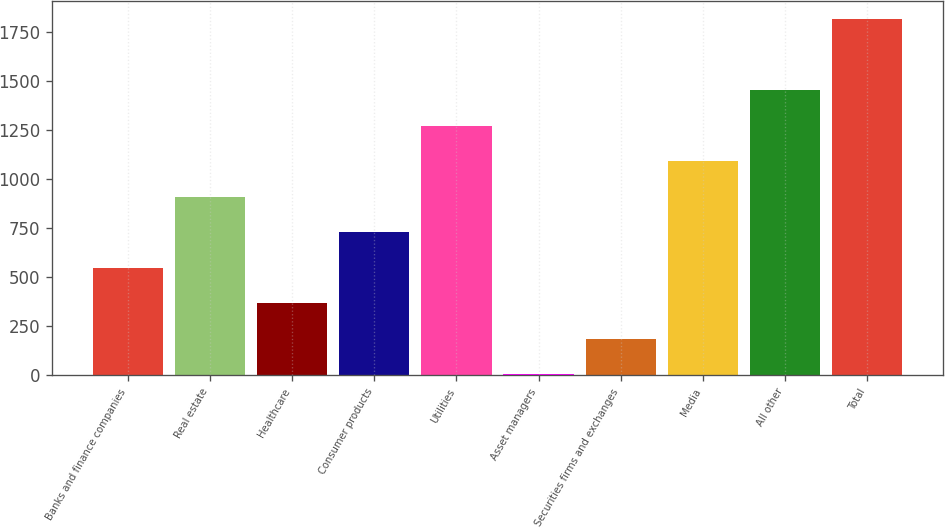Convert chart to OTSL. <chart><loc_0><loc_0><loc_500><loc_500><bar_chart><fcel>Banks and finance companies<fcel>Real estate<fcel>Healthcare<fcel>Consumer products<fcel>Utilities<fcel>Asset managers<fcel>Securities firms and exchanges<fcel>Media<fcel>All other<fcel>Total<nl><fcel>547.3<fcel>909.5<fcel>366.2<fcel>728.4<fcel>1271.7<fcel>4<fcel>185.1<fcel>1090.6<fcel>1452.8<fcel>1815<nl></chart> 